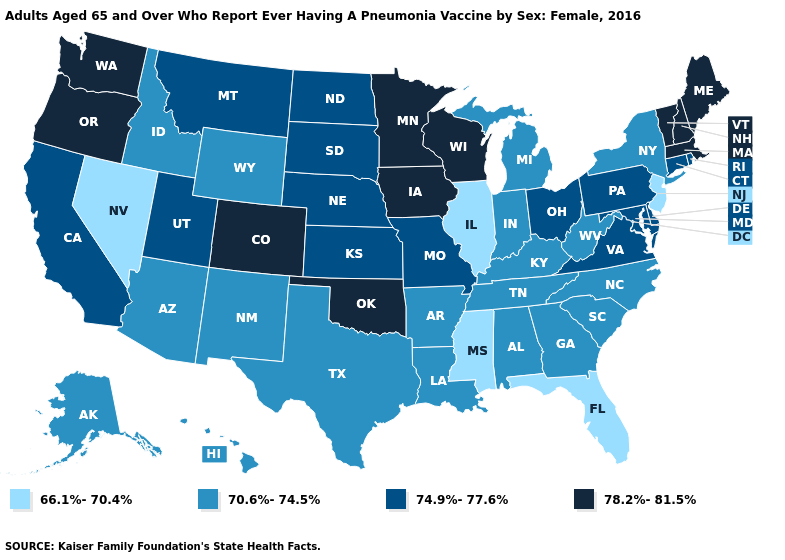What is the value of Wyoming?
Give a very brief answer. 70.6%-74.5%. Does Georgia have the same value as Nevada?
Write a very short answer. No. Among the states that border Idaho , does Montana have the highest value?
Give a very brief answer. No. What is the value of Idaho?
Give a very brief answer. 70.6%-74.5%. Does Ohio have the highest value in the MidWest?
Short answer required. No. Name the states that have a value in the range 66.1%-70.4%?
Write a very short answer. Florida, Illinois, Mississippi, Nevada, New Jersey. Does the map have missing data?
Keep it brief. No. Which states have the lowest value in the West?
Short answer required. Nevada. Does Maine have the highest value in the USA?
Give a very brief answer. Yes. What is the value of Delaware?
Concise answer only. 74.9%-77.6%. Does South Dakota have a higher value than Hawaii?
Write a very short answer. Yes. What is the value of Ohio?
Answer briefly. 74.9%-77.6%. Name the states that have a value in the range 74.9%-77.6%?
Short answer required. California, Connecticut, Delaware, Kansas, Maryland, Missouri, Montana, Nebraska, North Dakota, Ohio, Pennsylvania, Rhode Island, South Dakota, Utah, Virginia. Which states have the highest value in the USA?
Be succinct. Colorado, Iowa, Maine, Massachusetts, Minnesota, New Hampshire, Oklahoma, Oregon, Vermont, Washington, Wisconsin. What is the value of New Mexico?
Concise answer only. 70.6%-74.5%. 